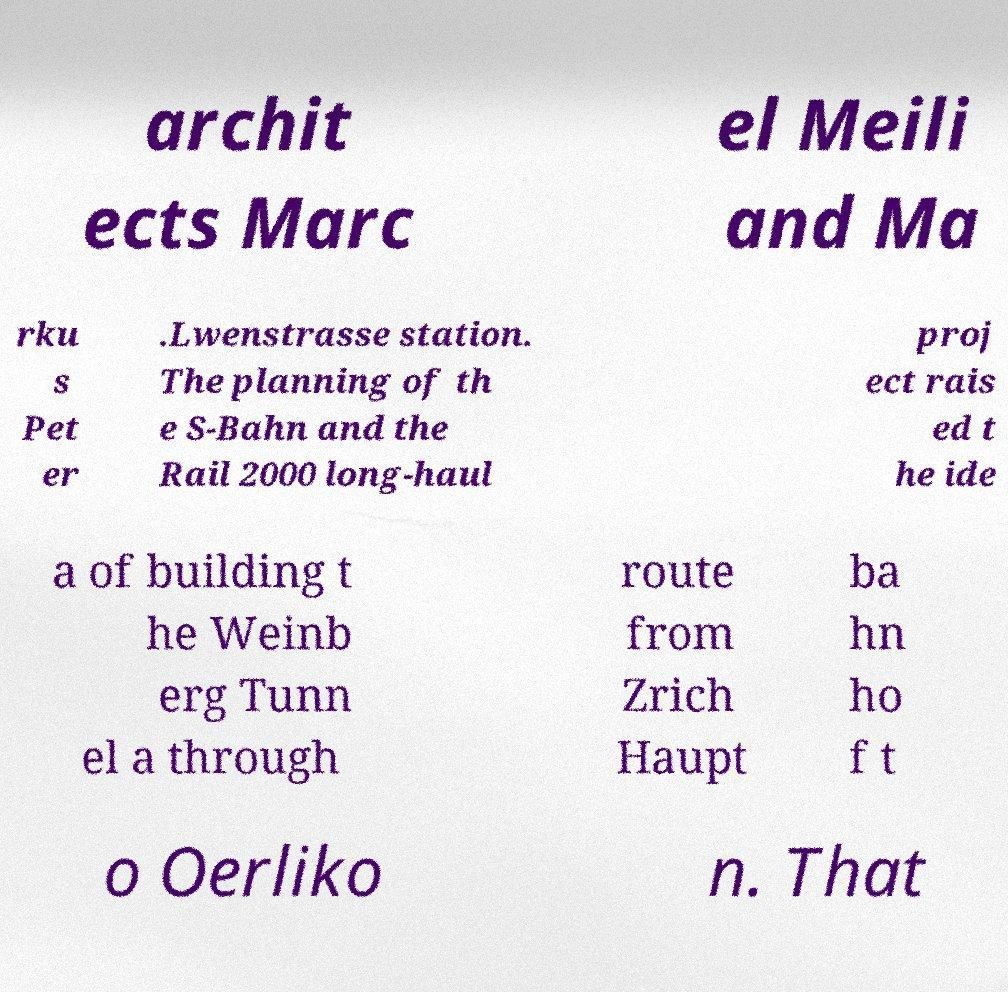What messages or text are displayed in this image? I need them in a readable, typed format. archit ects Marc el Meili and Ma rku s Pet er .Lwenstrasse station. The planning of th e S-Bahn and the Rail 2000 long-haul proj ect rais ed t he ide a of building t he Weinb erg Tunn el a through route from Zrich Haupt ba hn ho f t o Oerliko n. That 